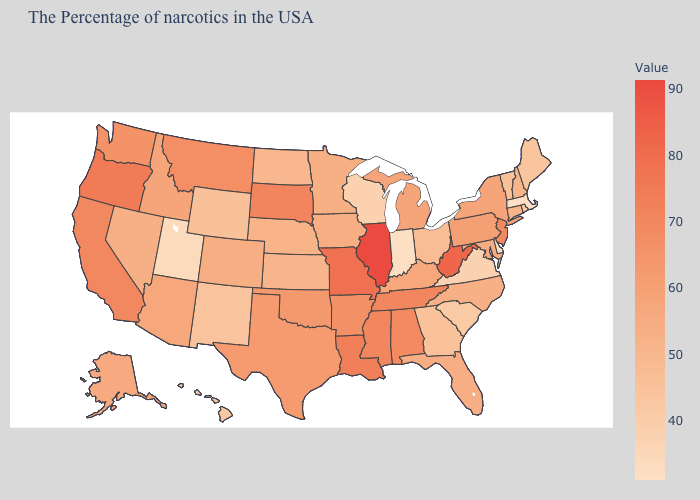Does the map have missing data?
Write a very short answer. No. Does Iowa have the lowest value in the MidWest?
Short answer required. No. Among the states that border California , does Oregon have the highest value?
Give a very brief answer. Yes. Which states hav the highest value in the MidWest?
Short answer required. Illinois. 